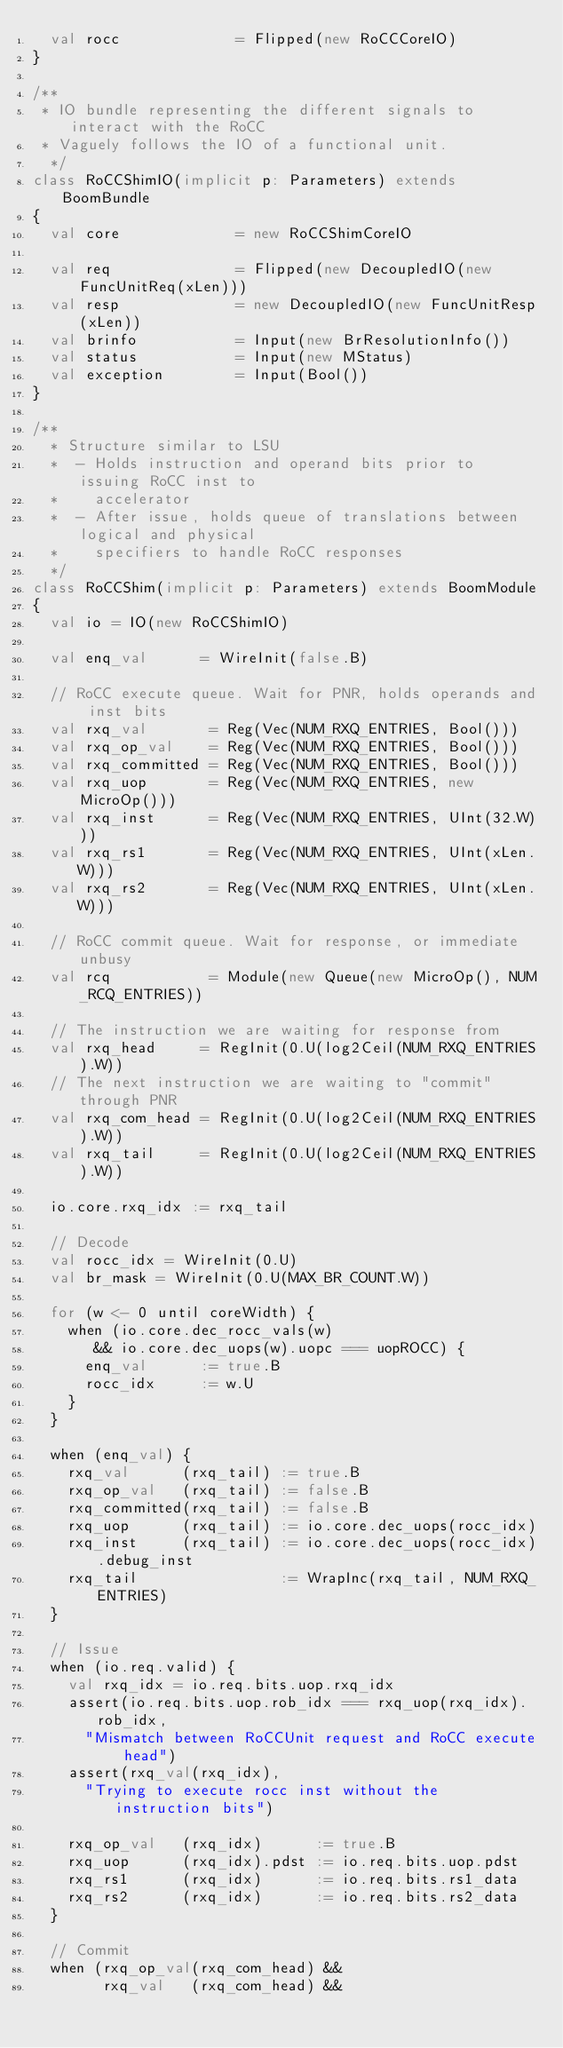Convert code to text. <code><loc_0><loc_0><loc_500><loc_500><_Scala_>  val rocc             = Flipped(new RoCCCoreIO)
}

/**
 * IO bundle representing the different signals to interact with the RoCC
 * Vaguely follows the IO of a functional unit.
  */
class RoCCShimIO(implicit p: Parameters) extends BoomBundle
{
  val core             = new RoCCShimCoreIO

  val req              = Flipped(new DecoupledIO(new FuncUnitReq(xLen)))
  val resp             = new DecoupledIO(new FuncUnitResp(xLen))
  val brinfo           = Input(new BrResolutionInfo())
  val status           = Input(new MStatus)
  val exception        = Input(Bool())
}

/**
  * Structure similar to LSU
  *  - Holds instruction and operand bits prior to issuing RoCC inst to
  *    accelerator
  *  - After issue, holds queue of translations between logical and physical
  *    specifiers to handle RoCC responses
  */
class RoCCShim(implicit p: Parameters) extends BoomModule
{
  val io = IO(new RoCCShimIO)

  val enq_val      = WireInit(false.B)

  // RoCC execute queue. Wait for PNR, holds operands and inst bits
  val rxq_val       = Reg(Vec(NUM_RXQ_ENTRIES, Bool()))
  val rxq_op_val    = Reg(Vec(NUM_RXQ_ENTRIES, Bool()))
  val rxq_committed = Reg(Vec(NUM_RXQ_ENTRIES, Bool()))
  val rxq_uop       = Reg(Vec(NUM_RXQ_ENTRIES, new MicroOp()))
  val rxq_inst      = Reg(Vec(NUM_RXQ_ENTRIES, UInt(32.W)))
  val rxq_rs1       = Reg(Vec(NUM_RXQ_ENTRIES, UInt(xLen.W)))
  val rxq_rs2       = Reg(Vec(NUM_RXQ_ENTRIES, UInt(xLen.W)))

  // RoCC commit queue. Wait for response, or immediate unbusy
  val rcq           = Module(new Queue(new MicroOp(), NUM_RCQ_ENTRIES))

  // The instruction we are waiting for response from
  val rxq_head     = RegInit(0.U(log2Ceil(NUM_RXQ_ENTRIES).W))
  // The next instruction we are waiting to "commit" through PNR
  val rxq_com_head = RegInit(0.U(log2Ceil(NUM_RXQ_ENTRIES).W))
  val rxq_tail     = RegInit(0.U(log2Ceil(NUM_RXQ_ENTRIES).W))

  io.core.rxq_idx := rxq_tail

  // Decode
  val rocc_idx = WireInit(0.U)
  val br_mask = WireInit(0.U(MAX_BR_COUNT.W))

  for (w <- 0 until coreWidth) {
    when (io.core.dec_rocc_vals(w)
       && io.core.dec_uops(w).uopc === uopROCC) {
      enq_val      := true.B
      rocc_idx     := w.U
    }
  }

  when (enq_val) {
    rxq_val      (rxq_tail) := true.B
    rxq_op_val   (rxq_tail) := false.B
    rxq_committed(rxq_tail) := false.B
    rxq_uop      (rxq_tail) := io.core.dec_uops(rocc_idx)
    rxq_inst     (rxq_tail) := io.core.dec_uops(rocc_idx).debug_inst
    rxq_tail                := WrapInc(rxq_tail, NUM_RXQ_ENTRIES)
  }

  // Issue
  when (io.req.valid) {
    val rxq_idx = io.req.bits.uop.rxq_idx
    assert(io.req.bits.uop.rob_idx === rxq_uop(rxq_idx).rob_idx,
      "Mismatch between RoCCUnit request and RoCC execute head")
    assert(rxq_val(rxq_idx),
      "Trying to execute rocc inst without the instruction bits")

    rxq_op_val   (rxq_idx)      := true.B
    rxq_uop      (rxq_idx).pdst := io.req.bits.uop.pdst
    rxq_rs1      (rxq_idx)      := io.req.bits.rs1_data
    rxq_rs2      (rxq_idx)      := io.req.bits.rs2_data
  }

  // Commit
  when (rxq_op_val(rxq_com_head) &&
        rxq_val   (rxq_com_head) &&</code> 